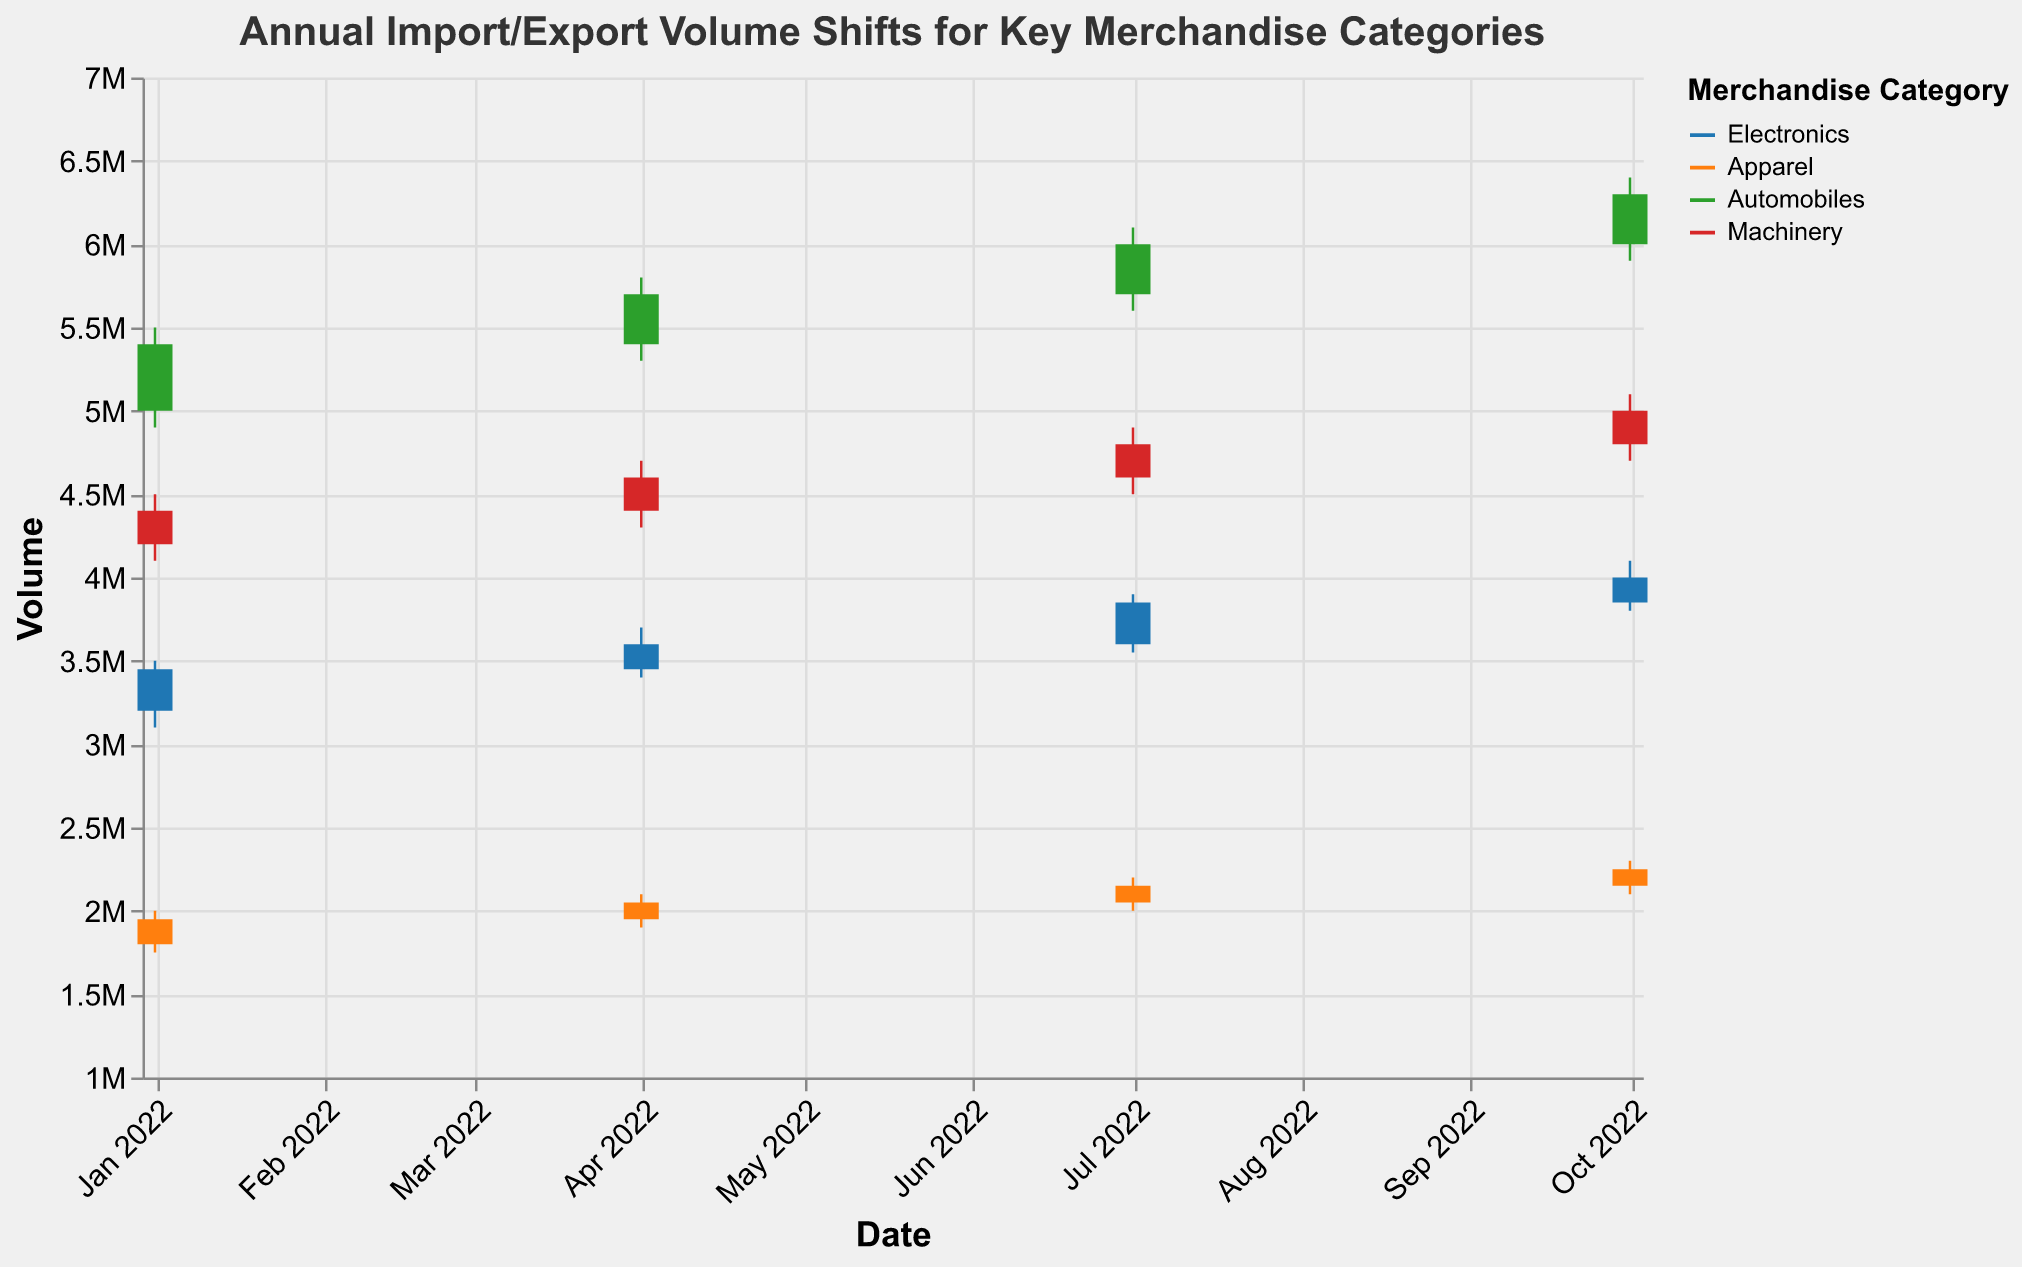What's the title of the figure? The title is displayed at the top of the chart.
Answer: Annual Import/Export Volume Shifts for Key Merchandise Categories Which merchandise category closes at the highest volume in the fourth quarter? Look at the "Close" volumes for the fourth quarter (2022-10-01) and identify the highest value among the categories.
Answer: Automobiles What was the volume range for the Electronics category in the first quarter (Q1)? Refer to the "High" and "Low" volumes for Electronics on 2022-01-01.
Answer: 3100000 to 3500000 Which category showed the most significant increase in close volume from Q1 to Q4? Calculate the difference between Q4 and Q1 "Close" volumes for each category and identify the largest increase.
Answer: Automobiles How did the Apparel category's volume change between Q1 and Q2? Compare the "Open" and "Close" volumes for Apparel on 2022-01-01 and 2022-04-01.
Answer: It increased What is the average "Close" volume for Machinery in 2022? Add up the "Close" volumes for Machinery for all four quarters and divide by 4.
Answer: 4700000 Did any category experience a decline in its "Close" volume from Q3 to Q4? Compare the "Close" volumes for Q3 and Q4 for each category to see if there's a decline.
Answer: No Which category has the widest volume range in Q2? Find the difference between "High" and "Low" volumes for each category in Q2 (2022-04-01) and identify the widest range.
Answer: Automobiles Across all categories, which quarter had the highest average "High" volume? Calculate the average "High" volume for each quarter by adding up the "High" volumes for all categories within that quarter and dividing by the number of categories.
Answer: Q4 What's the combined closing volume of Electronics for the first and second quarters of 2022? Add the "Close" volumes for Electronics on 2022-01-01 and 2022-04-01.
Answer: 7050000 